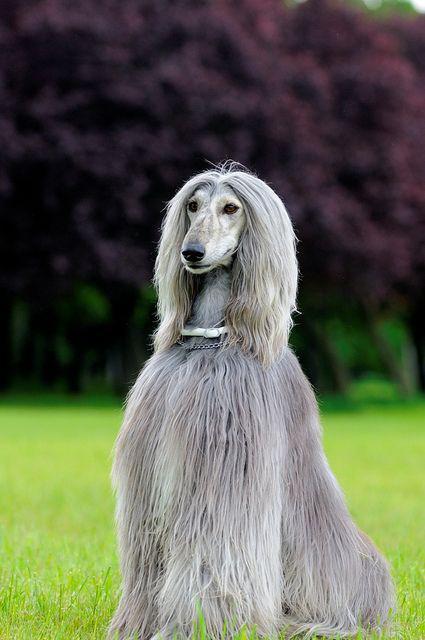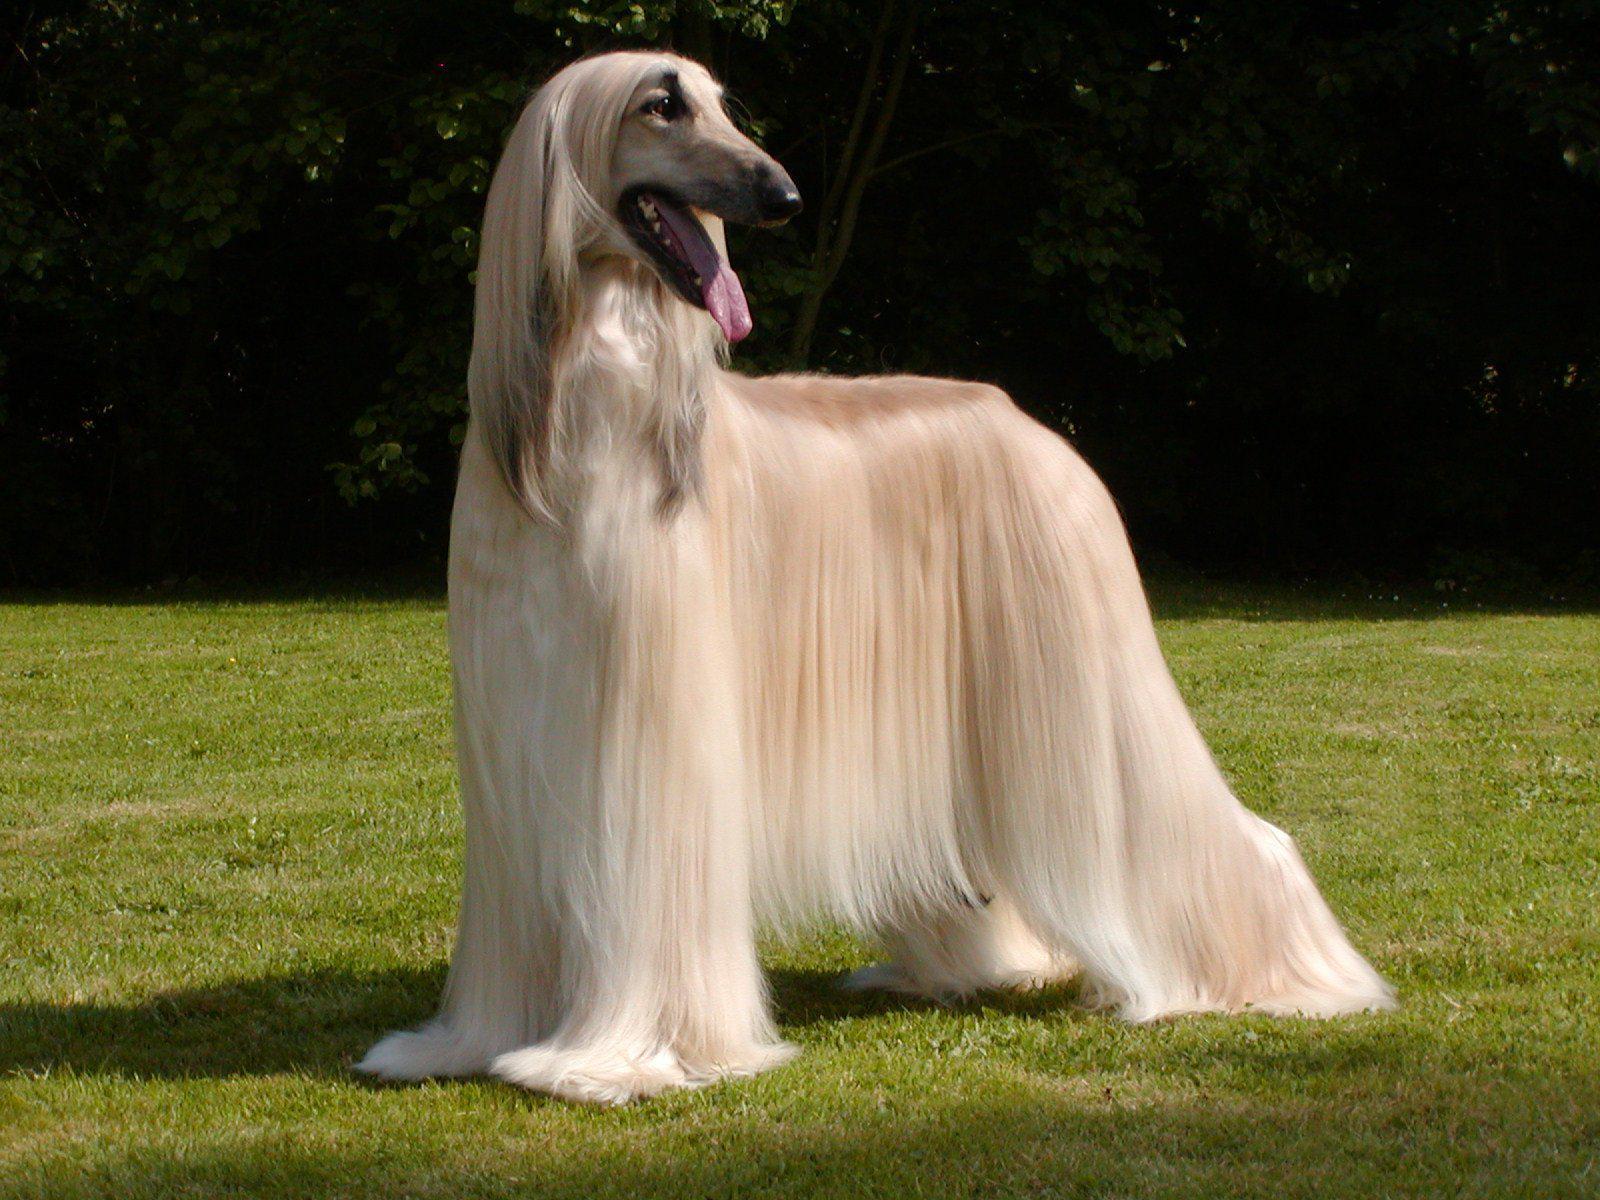The first image is the image on the left, the second image is the image on the right. Considering the images on both sides, is "One image has a dog facing left but looking to the right." valid? Answer yes or no. Yes. The first image is the image on the left, the second image is the image on the right. Evaluate the accuracy of this statement regarding the images: "In one image there is a lone afghan hound sitting outside in the grass.". Is it true? Answer yes or no. Yes. 